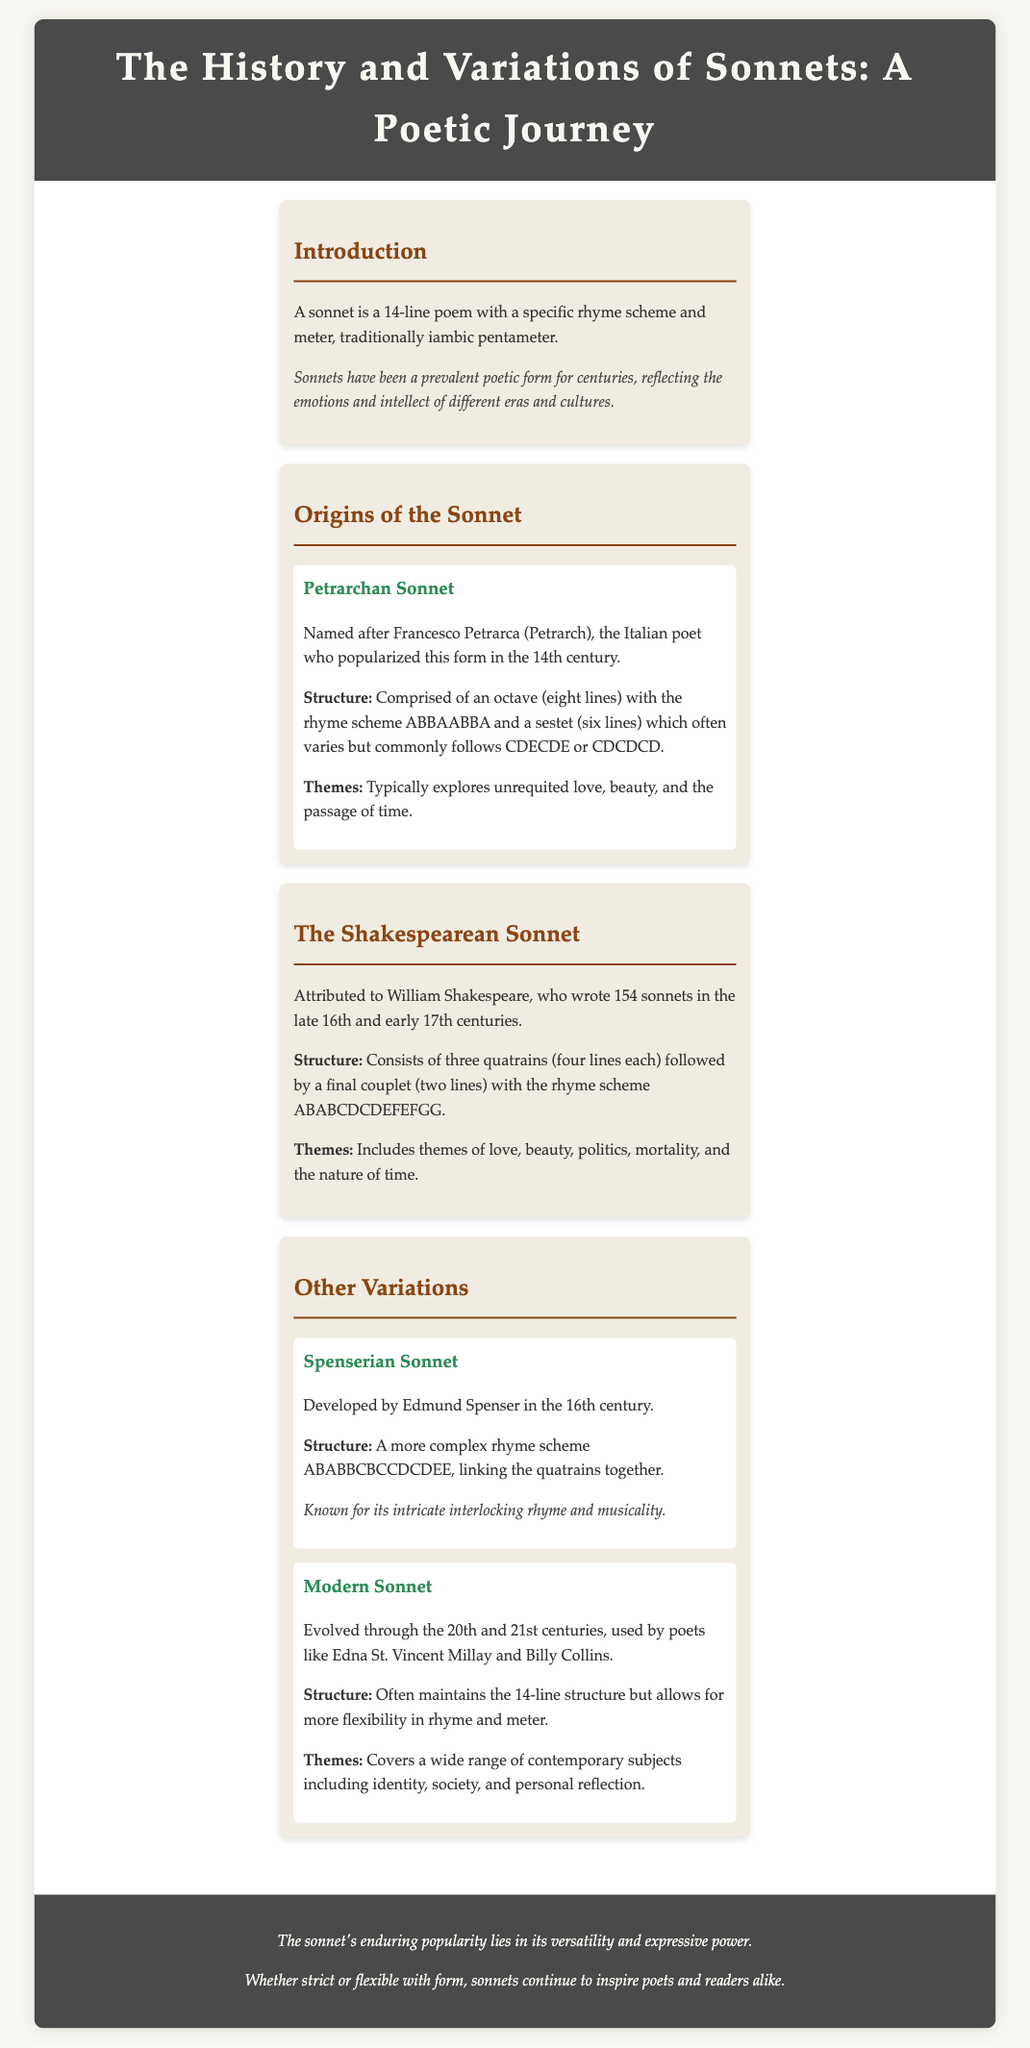What is the significance of the sonnet form? The sonnet has been a prevalent poetic form for centuries, reflecting the emotions and intellect of different eras and cultures.
Answer: Prevalent poetic form Who popularized the Petrarchan sonnet? The Petrarchan sonnet is named after Francesco Petrarca (Petrarch), the Italian poet who popularized this form in the 14th century.
Answer: Francesco Petrarca How many sonnets did William Shakespeare write? William Shakespeare wrote 154 sonnets in the late 16th and early 17th centuries.
Answer: 154 sonnets What is the rhyme scheme of a Shakespearean sonnet? The rhyme scheme of a Shakespearean sonnet consists of ABABCDCDEFEFGG.
Answer: ABABCDCDEFEFGG What theme is typically explored in Petrarchan sonnets? Petrarchan sonnets typically explore unrequited love, beauty, and the passage of time.
Answer: Unrequited love What characterizes a Spenserian sonnet? A Spenserian sonnet is known for its intricate interlocking rhyme and musicality.
Answer: Intricate interlocking rhyme What is a modern sonnet's approach to structure? Modern sonnets often maintain the 14-line structure but allow for more flexibility in rhyme and meter.
Answer: Flexibility in rhyme and meter Why is the sonnet form enduringly popular? The sonnet's enduring popularity lies in its versatility and expressive power.
Answer: Versatility and expressive power 